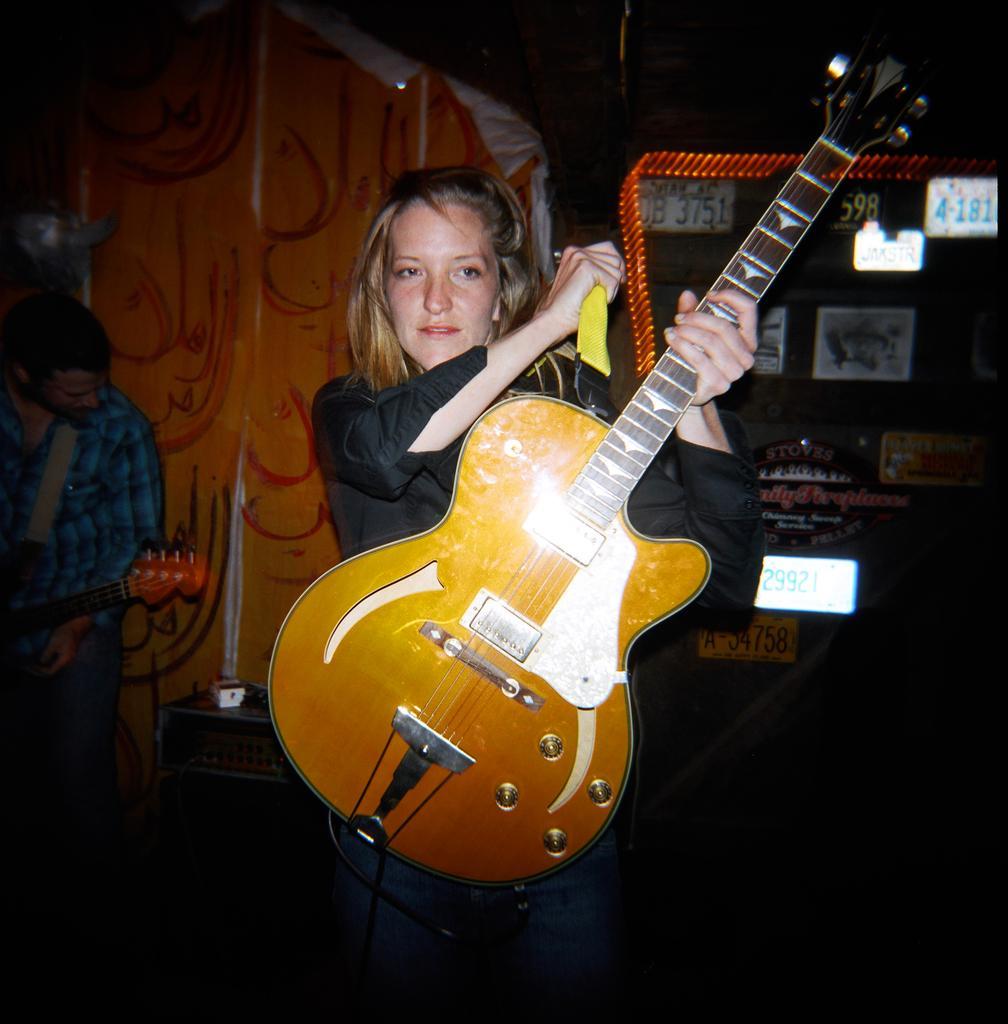Can you describe this image briefly? In this image i can see a person holding a guitar and left side i can see a person holding a guitar ,back side of the woman i can see a numbers on the wall. 